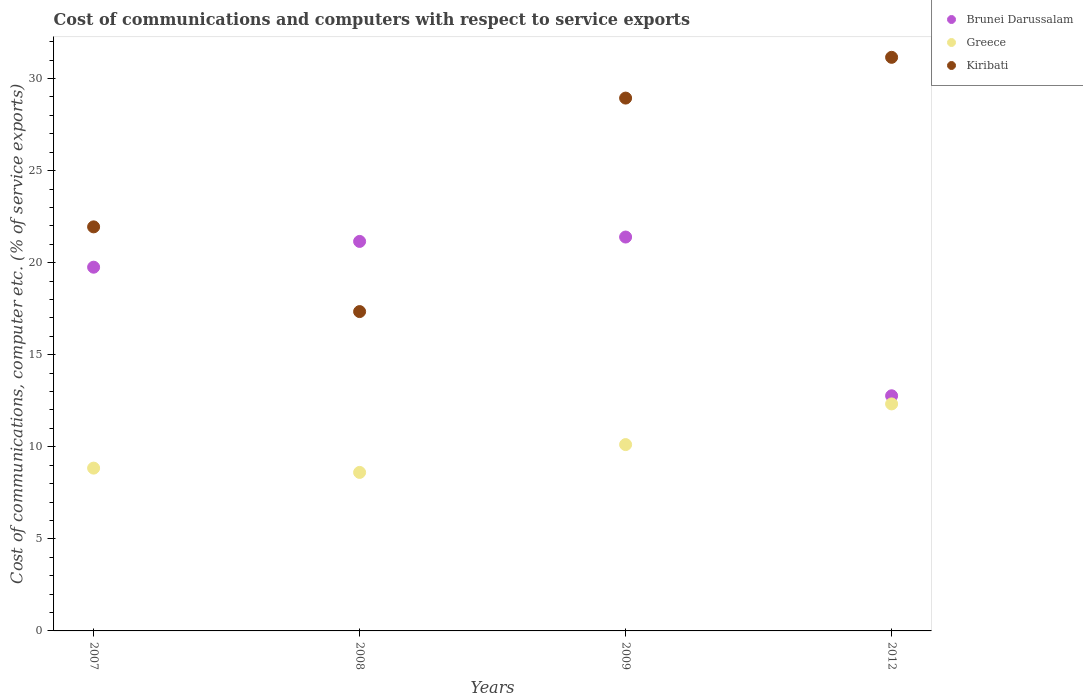Is the number of dotlines equal to the number of legend labels?
Make the answer very short. Yes. What is the cost of communications and computers in Greece in 2012?
Your response must be concise. 12.33. Across all years, what is the maximum cost of communications and computers in Brunei Darussalam?
Provide a succinct answer. 21.39. Across all years, what is the minimum cost of communications and computers in Brunei Darussalam?
Offer a terse response. 12.77. In which year was the cost of communications and computers in Brunei Darussalam maximum?
Offer a terse response. 2009. In which year was the cost of communications and computers in Brunei Darussalam minimum?
Provide a succinct answer. 2012. What is the total cost of communications and computers in Greece in the graph?
Make the answer very short. 39.9. What is the difference between the cost of communications and computers in Kiribati in 2007 and that in 2009?
Give a very brief answer. -6.99. What is the difference between the cost of communications and computers in Kiribati in 2012 and the cost of communications and computers in Greece in 2009?
Offer a terse response. 21.03. What is the average cost of communications and computers in Kiribati per year?
Your answer should be very brief. 24.84. In the year 2012, what is the difference between the cost of communications and computers in Greece and cost of communications and computers in Brunei Darussalam?
Provide a short and direct response. -0.44. What is the ratio of the cost of communications and computers in Greece in 2007 to that in 2008?
Provide a succinct answer. 1.03. What is the difference between the highest and the second highest cost of communications and computers in Brunei Darussalam?
Your answer should be very brief. 0.24. What is the difference between the highest and the lowest cost of communications and computers in Kiribati?
Give a very brief answer. 13.81. In how many years, is the cost of communications and computers in Brunei Darussalam greater than the average cost of communications and computers in Brunei Darussalam taken over all years?
Ensure brevity in your answer.  3. Does the cost of communications and computers in Kiribati monotonically increase over the years?
Your response must be concise. No. Is the cost of communications and computers in Kiribati strictly less than the cost of communications and computers in Greece over the years?
Offer a very short reply. No. How many dotlines are there?
Your answer should be compact. 3. What is the difference between two consecutive major ticks on the Y-axis?
Your response must be concise. 5. Are the values on the major ticks of Y-axis written in scientific E-notation?
Provide a succinct answer. No. Does the graph contain grids?
Ensure brevity in your answer.  No. What is the title of the graph?
Offer a terse response. Cost of communications and computers with respect to service exports. Does "Samoa" appear as one of the legend labels in the graph?
Provide a succinct answer. No. What is the label or title of the Y-axis?
Provide a short and direct response. Cost of communications, computer etc. (% of service exports). What is the Cost of communications, computer etc. (% of service exports) of Brunei Darussalam in 2007?
Provide a short and direct response. 19.75. What is the Cost of communications, computer etc. (% of service exports) in Greece in 2007?
Your answer should be compact. 8.84. What is the Cost of communications, computer etc. (% of service exports) of Kiribati in 2007?
Ensure brevity in your answer.  21.94. What is the Cost of communications, computer etc. (% of service exports) of Brunei Darussalam in 2008?
Your answer should be compact. 21.15. What is the Cost of communications, computer etc. (% of service exports) in Greece in 2008?
Your answer should be compact. 8.61. What is the Cost of communications, computer etc. (% of service exports) in Kiribati in 2008?
Your response must be concise. 17.34. What is the Cost of communications, computer etc. (% of service exports) of Brunei Darussalam in 2009?
Ensure brevity in your answer.  21.39. What is the Cost of communications, computer etc. (% of service exports) of Greece in 2009?
Offer a terse response. 10.12. What is the Cost of communications, computer etc. (% of service exports) in Kiribati in 2009?
Give a very brief answer. 28.94. What is the Cost of communications, computer etc. (% of service exports) in Brunei Darussalam in 2012?
Offer a terse response. 12.77. What is the Cost of communications, computer etc. (% of service exports) of Greece in 2012?
Your answer should be compact. 12.33. What is the Cost of communications, computer etc. (% of service exports) of Kiribati in 2012?
Give a very brief answer. 31.15. Across all years, what is the maximum Cost of communications, computer etc. (% of service exports) in Brunei Darussalam?
Offer a very short reply. 21.39. Across all years, what is the maximum Cost of communications, computer etc. (% of service exports) of Greece?
Your answer should be compact. 12.33. Across all years, what is the maximum Cost of communications, computer etc. (% of service exports) of Kiribati?
Give a very brief answer. 31.15. Across all years, what is the minimum Cost of communications, computer etc. (% of service exports) in Brunei Darussalam?
Keep it short and to the point. 12.77. Across all years, what is the minimum Cost of communications, computer etc. (% of service exports) in Greece?
Offer a very short reply. 8.61. Across all years, what is the minimum Cost of communications, computer etc. (% of service exports) of Kiribati?
Provide a short and direct response. 17.34. What is the total Cost of communications, computer etc. (% of service exports) in Brunei Darussalam in the graph?
Provide a succinct answer. 75.07. What is the total Cost of communications, computer etc. (% of service exports) in Greece in the graph?
Offer a very short reply. 39.9. What is the total Cost of communications, computer etc. (% of service exports) of Kiribati in the graph?
Your answer should be very brief. 99.38. What is the difference between the Cost of communications, computer etc. (% of service exports) in Brunei Darussalam in 2007 and that in 2008?
Offer a very short reply. -1.4. What is the difference between the Cost of communications, computer etc. (% of service exports) of Greece in 2007 and that in 2008?
Your answer should be compact. 0.23. What is the difference between the Cost of communications, computer etc. (% of service exports) in Kiribati in 2007 and that in 2008?
Offer a terse response. 4.6. What is the difference between the Cost of communications, computer etc. (% of service exports) in Brunei Darussalam in 2007 and that in 2009?
Provide a short and direct response. -1.64. What is the difference between the Cost of communications, computer etc. (% of service exports) of Greece in 2007 and that in 2009?
Your answer should be compact. -1.28. What is the difference between the Cost of communications, computer etc. (% of service exports) in Kiribati in 2007 and that in 2009?
Your response must be concise. -6.99. What is the difference between the Cost of communications, computer etc. (% of service exports) in Brunei Darussalam in 2007 and that in 2012?
Offer a very short reply. 6.98. What is the difference between the Cost of communications, computer etc. (% of service exports) in Greece in 2007 and that in 2012?
Offer a terse response. -3.49. What is the difference between the Cost of communications, computer etc. (% of service exports) in Kiribati in 2007 and that in 2012?
Ensure brevity in your answer.  -9.21. What is the difference between the Cost of communications, computer etc. (% of service exports) in Brunei Darussalam in 2008 and that in 2009?
Provide a short and direct response. -0.24. What is the difference between the Cost of communications, computer etc. (% of service exports) of Greece in 2008 and that in 2009?
Your response must be concise. -1.51. What is the difference between the Cost of communications, computer etc. (% of service exports) of Kiribati in 2008 and that in 2009?
Your answer should be compact. -11.59. What is the difference between the Cost of communications, computer etc. (% of service exports) of Brunei Darussalam in 2008 and that in 2012?
Provide a succinct answer. 8.38. What is the difference between the Cost of communications, computer etc. (% of service exports) in Greece in 2008 and that in 2012?
Make the answer very short. -3.72. What is the difference between the Cost of communications, computer etc. (% of service exports) in Kiribati in 2008 and that in 2012?
Give a very brief answer. -13.81. What is the difference between the Cost of communications, computer etc. (% of service exports) of Brunei Darussalam in 2009 and that in 2012?
Keep it short and to the point. 8.62. What is the difference between the Cost of communications, computer etc. (% of service exports) of Greece in 2009 and that in 2012?
Keep it short and to the point. -2.21. What is the difference between the Cost of communications, computer etc. (% of service exports) in Kiribati in 2009 and that in 2012?
Offer a terse response. -2.21. What is the difference between the Cost of communications, computer etc. (% of service exports) of Brunei Darussalam in 2007 and the Cost of communications, computer etc. (% of service exports) of Greece in 2008?
Your response must be concise. 11.15. What is the difference between the Cost of communications, computer etc. (% of service exports) in Brunei Darussalam in 2007 and the Cost of communications, computer etc. (% of service exports) in Kiribati in 2008?
Your response must be concise. 2.41. What is the difference between the Cost of communications, computer etc. (% of service exports) of Greece in 2007 and the Cost of communications, computer etc. (% of service exports) of Kiribati in 2008?
Make the answer very short. -8.5. What is the difference between the Cost of communications, computer etc. (% of service exports) of Brunei Darussalam in 2007 and the Cost of communications, computer etc. (% of service exports) of Greece in 2009?
Give a very brief answer. 9.63. What is the difference between the Cost of communications, computer etc. (% of service exports) in Brunei Darussalam in 2007 and the Cost of communications, computer etc. (% of service exports) in Kiribati in 2009?
Make the answer very short. -9.18. What is the difference between the Cost of communications, computer etc. (% of service exports) in Greece in 2007 and the Cost of communications, computer etc. (% of service exports) in Kiribati in 2009?
Your answer should be compact. -20.1. What is the difference between the Cost of communications, computer etc. (% of service exports) of Brunei Darussalam in 2007 and the Cost of communications, computer etc. (% of service exports) of Greece in 2012?
Provide a short and direct response. 7.43. What is the difference between the Cost of communications, computer etc. (% of service exports) of Brunei Darussalam in 2007 and the Cost of communications, computer etc. (% of service exports) of Kiribati in 2012?
Your answer should be very brief. -11.4. What is the difference between the Cost of communications, computer etc. (% of service exports) in Greece in 2007 and the Cost of communications, computer etc. (% of service exports) in Kiribati in 2012?
Offer a very short reply. -22.31. What is the difference between the Cost of communications, computer etc. (% of service exports) of Brunei Darussalam in 2008 and the Cost of communications, computer etc. (% of service exports) of Greece in 2009?
Provide a short and direct response. 11.03. What is the difference between the Cost of communications, computer etc. (% of service exports) in Brunei Darussalam in 2008 and the Cost of communications, computer etc. (% of service exports) in Kiribati in 2009?
Your response must be concise. -7.78. What is the difference between the Cost of communications, computer etc. (% of service exports) in Greece in 2008 and the Cost of communications, computer etc. (% of service exports) in Kiribati in 2009?
Provide a succinct answer. -20.33. What is the difference between the Cost of communications, computer etc. (% of service exports) of Brunei Darussalam in 2008 and the Cost of communications, computer etc. (% of service exports) of Greece in 2012?
Provide a short and direct response. 8.83. What is the difference between the Cost of communications, computer etc. (% of service exports) of Brunei Darussalam in 2008 and the Cost of communications, computer etc. (% of service exports) of Kiribati in 2012?
Offer a very short reply. -10. What is the difference between the Cost of communications, computer etc. (% of service exports) of Greece in 2008 and the Cost of communications, computer etc. (% of service exports) of Kiribati in 2012?
Make the answer very short. -22.54. What is the difference between the Cost of communications, computer etc. (% of service exports) in Brunei Darussalam in 2009 and the Cost of communications, computer etc. (% of service exports) in Greece in 2012?
Give a very brief answer. 9.06. What is the difference between the Cost of communications, computer etc. (% of service exports) in Brunei Darussalam in 2009 and the Cost of communications, computer etc. (% of service exports) in Kiribati in 2012?
Keep it short and to the point. -9.76. What is the difference between the Cost of communications, computer etc. (% of service exports) of Greece in 2009 and the Cost of communications, computer etc. (% of service exports) of Kiribati in 2012?
Your answer should be compact. -21.03. What is the average Cost of communications, computer etc. (% of service exports) of Brunei Darussalam per year?
Give a very brief answer. 18.77. What is the average Cost of communications, computer etc. (% of service exports) of Greece per year?
Offer a terse response. 9.97. What is the average Cost of communications, computer etc. (% of service exports) of Kiribati per year?
Provide a short and direct response. 24.84. In the year 2007, what is the difference between the Cost of communications, computer etc. (% of service exports) of Brunei Darussalam and Cost of communications, computer etc. (% of service exports) of Greece?
Offer a very short reply. 10.91. In the year 2007, what is the difference between the Cost of communications, computer etc. (% of service exports) of Brunei Darussalam and Cost of communications, computer etc. (% of service exports) of Kiribati?
Ensure brevity in your answer.  -2.19. In the year 2007, what is the difference between the Cost of communications, computer etc. (% of service exports) in Greece and Cost of communications, computer etc. (% of service exports) in Kiribati?
Keep it short and to the point. -13.1. In the year 2008, what is the difference between the Cost of communications, computer etc. (% of service exports) of Brunei Darussalam and Cost of communications, computer etc. (% of service exports) of Greece?
Make the answer very short. 12.55. In the year 2008, what is the difference between the Cost of communications, computer etc. (% of service exports) in Brunei Darussalam and Cost of communications, computer etc. (% of service exports) in Kiribati?
Offer a terse response. 3.81. In the year 2008, what is the difference between the Cost of communications, computer etc. (% of service exports) of Greece and Cost of communications, computer etc. (% of service exports) of Kiribati?
Offer a very short reply. -8.73. In the year 2009, what is the difference between the Cost of communications, computer etc. (% of service exports) of Brunei Darussalam and Cost of communications, computer etc. (% of service exports) of Greece?
Your answer should be very brief. 11.27. In the year 2009, what is the difference between the Cost of communications, computer etc. (% of service exports) of Brunei Darussalam and Cost of communications, computer etc. (% of service exports) of Kiribati?
Offer a very short reply. -7.55. In the year 2009, what is the difference between the Cost of communications, computer etc. (% of service exports) in Greece and Cost of communications, computer etc. (% of service exports) in Kiribati?
Your answer should be very brief. -18.82. In the year 2012, what is the difference between the Cost of communications, computer etc. (% of service exports) in Brunei Darussalam and Cost of communications, computer etc. (% of service exports) in Greece?
Make the answer very short. 0.44. In the year 2012, what is the difference between the Cost of communications, computer etc. (% of service exports) of Brunei Darussalam and Cost of communications, computer etc. (% of service exports) of Kiribati?
Provide a short and direct response. -18.38. In the year 2012, what is the difference between the Cost of communications, computer etc. (% of service exports) in Greece and Cost of communications, computer etc. (% of service exports) in Kiribati?
Offer a very short reply. -18.82. What is the ratio of the Cost of communications, computer etc. (% of service exports) in Brunei Darussalam in 2007 to that in 2008?
Keep it short and to the point. 0.93. What is the ratio of the Cost of communications, computer etc. (% of service exports) in Greece in 2007 to that in 2008?
Offer a very short reply. 1.03. What is the ratio of the Cost of communications, computer etc. (% of service exports) of Kiribati in 2007 to that in 2008?
Provide a succinct answer. 1.27. What is the ratio of the Cost of communications, computer etc. (% of service exports) in Brunei Darussalam in 2007 to that in 2009?
Give a very brief answer. 0.92. What is the ratio of the Cost of communications, computer etc. (% of service exports) of Greece in 2007 to that in 2009?
Offer a terse response. 0.87. What is the ratio of the Cost of communications, computer etc. (% of service exports) of Kiribati in 2007 to that in 2009?
Make the answer very short. 0.76. What is the ratio of the Cost of communications, computer etc. (% of service exports) in Brunei Darussalam in 2007 to that in 2012?
Provide a succinct answer. 1.55. What is the ratio of the Cost of communications, computer etc. (% of service exports) in Greece in 2007 to that in 2012?
Keep it short and to the point. 0.72. What is the ratio of the Cost of communications, computer etc. (% of service exports) in Kiribati in 2007 to that in 2012?
Provide a succinct answer. 0.7. What is the ratio of the Cost of communications, computer etc. (% of service exports) in Brunei Darussalam in 2008 to that in 2009?
Keep it short and to the point. 0.99. What is the ratio of the Cost of communications, computer etc. (% of service exports) of Greece in 2008 to that in 2009?
Make the answer very short. 0.85. What is the ratio of the Cost of communications, computer etc. (% of service exports) of Kiribati in 2008 to that in 2009?
Keep it short and to the point. 0.6. What is the ratio of the Cost of communications, computer etc. (% of service exports) of Brunei Darussalam in 2008 to that in 2012?
Make the answer very short. 1.66. What is the ratio of the Cost of communications, computer etc. (% of service exports) of Greece in 2008 to that in 2012?
Offer a very short reply. 0.7. What is the ratio of the Cost of communications, computer etc. (% of service exports) of Kiribati in 2008 to that in 2012?
Keep it short and to the point. 0.56. What is the ratio of the Cost of communications, computer etc. (% of service exports) in Brunei Darussalam in 2009 to that in 2012?
Provide a succinct answer. 1.68. What is the ratio of the Cost of communications, computer etc. (% of service exports) of Greece in 2009 to that in 2012?
Your answer should be very brief. 0.82. What is the ratio of the Cost of communications, computer etc. (% of service exports) in Kiribati in 2009 to that in 2012?
Give a very brief answer. 0.93. What is the difference between the highest and the second highest Cost of communications, computer etc. (% of service exports) of Brunei Darussalam?
Offer a terse response. 0.24. What is the difference between the highest and the second highest Cost of communications, computer etc. (% of service exports) in Greece?
Provide a short and direct response. 2.21. What is the difference between the highest and the second highest Cost of communications, computer etc. (% of service exports) of Kiribati?
Offer a very short reply. 2.21. What is the difference between the highest and the lowest Cost of communications, computer etc. (% of service exports) of Brunei Darussalam?
Offer a very short reply. 8.62. What is the difference between the highest and the lowest Cost of communications, computer etc. (% of service exports) of Greece?
Keep it short and to the point. 3.72. What is the difference between the highest and the lowest Cost of communications, computer etc. (% of service exports) in Kiribati?
Provide a short and direct response. 13.81. 